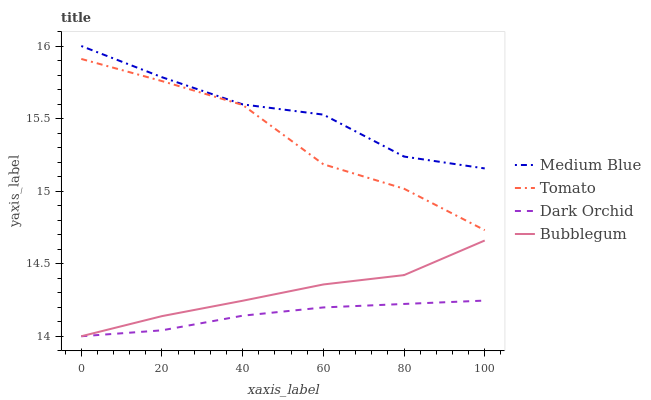Does Dark Orchid have the minimum area under the curve?
Answer yes or no. Yes. Does Medium Blue have the maximum area under the curve?
Answer yes or no. Yes. Does Bubblegum have the minimum area under the curve?
Answer yes or no. No. Does Bubblegum have the maximum area under the curve?
Answer yes or no. No. Is Dark Orchid the smoothest?
Answer yes or no. Yes. Is Tomato the roughest?
Answer yes or no. Yes. Is Medium Blue the smoothest?
Answer yes or no. No. Is Medium Blue the roughest?
Answer yes or no. No. Does Bubblegum have the lowest value?
Answer yes or no. Yes. Does Medium Blue have the lowest value?
Answer yes or no. No. Does Medium Blue have the highest value?
Answer yes or no. Yes. Does Bubblegum have the highest value?
Answer yes or no. No. Is Dark Orchid less than Tomato?
Answer yes or no. Yes. Is Medium Blue greater than Bubblegum?
Answer yes or no. Yes. Does Dark Orchid intersect Bubblegum?
Answer yes or no. Yes. Is Dark Orchid less than Bubblegum?
Answer yes or no. No. Is Dark Orchid greater than Bubblegum?
Answer yes or no. No. Does Dark Orchid intersect Tomato?
Answer yes or no. No. 